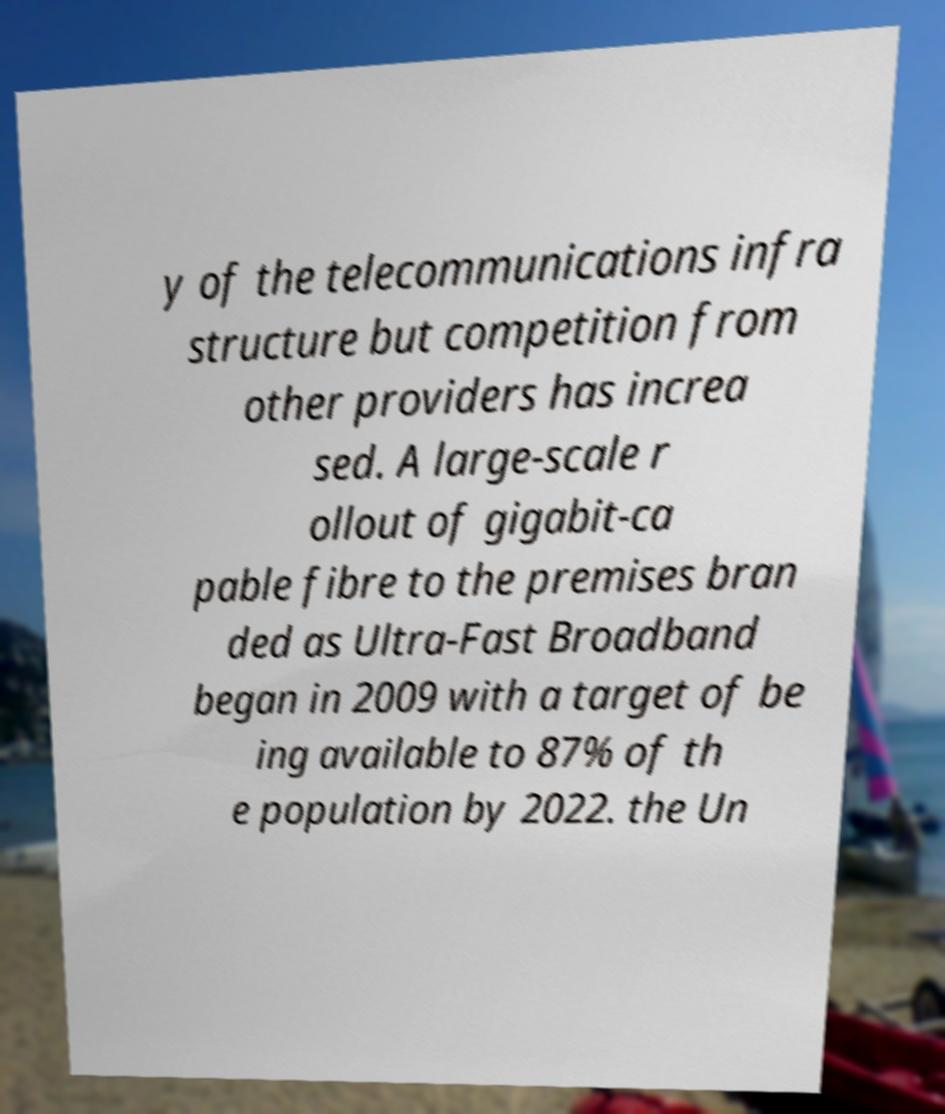Could you assist in decoding the text presented in this image and type it out clearly? y of the telecommunications infra structure but competition from other providers has increa sed. A large-scale r ollout of gigabit-ca pable fibre to the premises bran ded as Ultra-Fast Broadband began in 2009 with a target of be ing available to 87% of th e population by 2022. the Un 